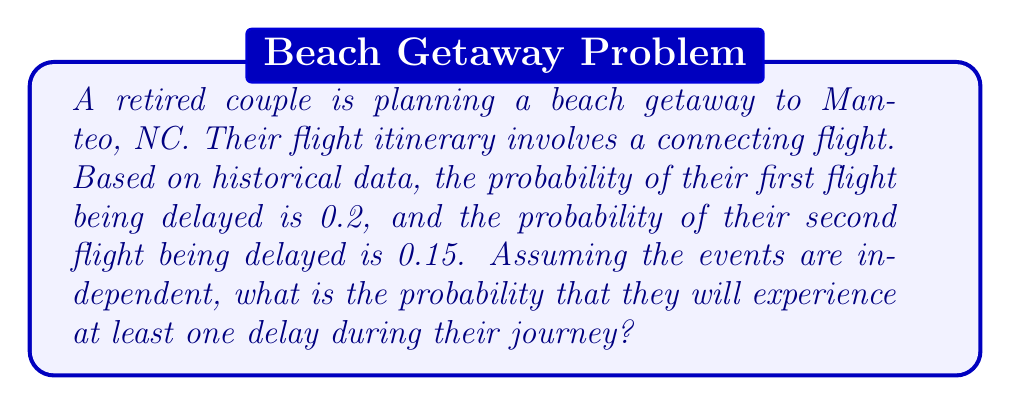Provide a solution to this math problem. Let's approach this step-by-step:

1) Let A be the event that the first flight is delayed, and B be the event that the second flight is delayed.

2) Given:
   P(A) = 0.2
   P(B) = 0.15

3) We need to find the probability of at least one delay, which is the same as 1 minus the probability of no delays.

4) The probability of no delays is the probability that both flights are on time:
   P(no delays) = P(not A and not B)

5) Since the events are independent:
   P(not A and not B) = P(not A) × P(not B)

6) P(not A) = 1 - P(A) = 1 - 0.2 = 0.8
   P(not B) = 1 - P(B) = 1 - 0.15 = 0.85

7) Therefore:
   P(no delays) = 0.8 × 0.85 = 0.68

8) The probability of at least one delay is:
   P(at least one delay) = 1 - P(no delays)
                         = 1 - 0.68
                         = 0.32

Thus, the probability of experiencing at least one delay is 0.32 or 32%.
Answer: 0.32 